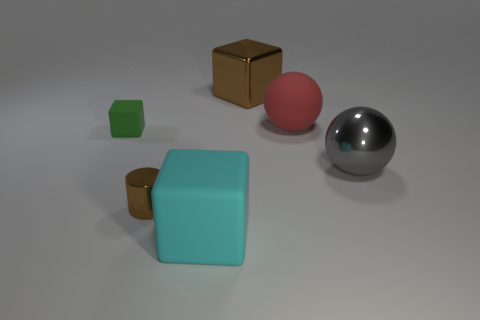Add 3 tiny brown metallic things. How many objects exist? 9 Subtract all spheres. How many objects are left? 4 Subtract all brown metal cubes. Subtract all green cubes. How many objects are left? 4 Add 1 brown objects. How many brown objects are left? 3 Add 6 large matte cubes. How many large matte cubes exist? 7 Subtract 0 cyan cylinders. How many objects are left? 6 